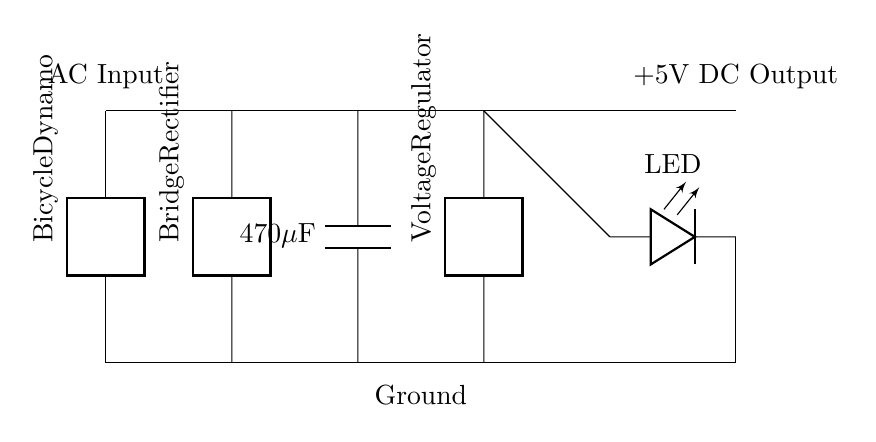What is the main source of power in this circuit? The main power source is the bicycle dynamo, which converts mechanical energy from pedaling into electrical energy.
Answer: Bicycle dynamo What type of rectifier is used? A bridge rectifier is used to convert the alternating current from the dynamo into direct current for the LED.
Answer: Bridge rectifier What component is used to smooth out the voltage? The component used is a capacitor, specifically a 470 microfarads capacitor, which helps to reduce voltage fluctuations.
Answer: 470 microfarads capacitor What is the output voltage of this circuit? The output voltage is 5 volts DC, which is the voltage provided to power the LED light.
Answer: 5 volts How does the voltage regulator function in this circuit? The voltage regulator controls the output voltage to ensure it remains stable at 5 volts, even if the input voltage varies from the dynamo.
Answer: Stabilizes output What is the purpose of the LED in this circuit? The LED serves as the load that utilizes the electrical energy produced by the dynamo and processed through the rectifier and voltage regulator.
Answer: Light source What indicates the direction of current flow in this circuit? The direction of current flow is indicated by the orientation of the components and wiring, which typically flows from the positive terminal of the rectifier to the LED and back to ground.
Answer: Current direction 